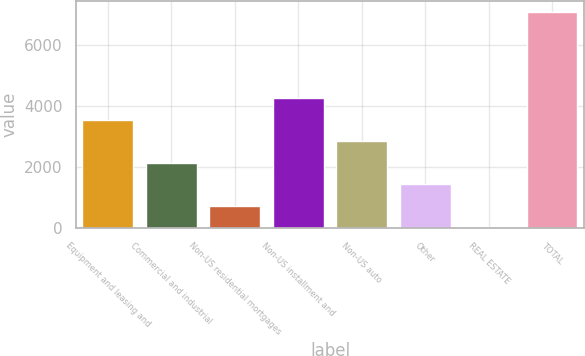Convert chart to OTSL. <chart><loc_0><loc_0><loc_500><loc_500><bar_chart><fcel>Equipment and leasing and<fcel>Commercial and industrial<fcel>Non-US residential mortgages<fcel>Non-US installment and<fcel>Non-US auto<fcel>Other<fcel>REAL ESTATE<fcel>TOTAL<nl><fcel>3550.5<fcel>2135.1<fcel>719.7<fcel>4258.2<fcel>2842.8<fcel>1427.4<fcel>12<fcel>7089<nl></chart> 